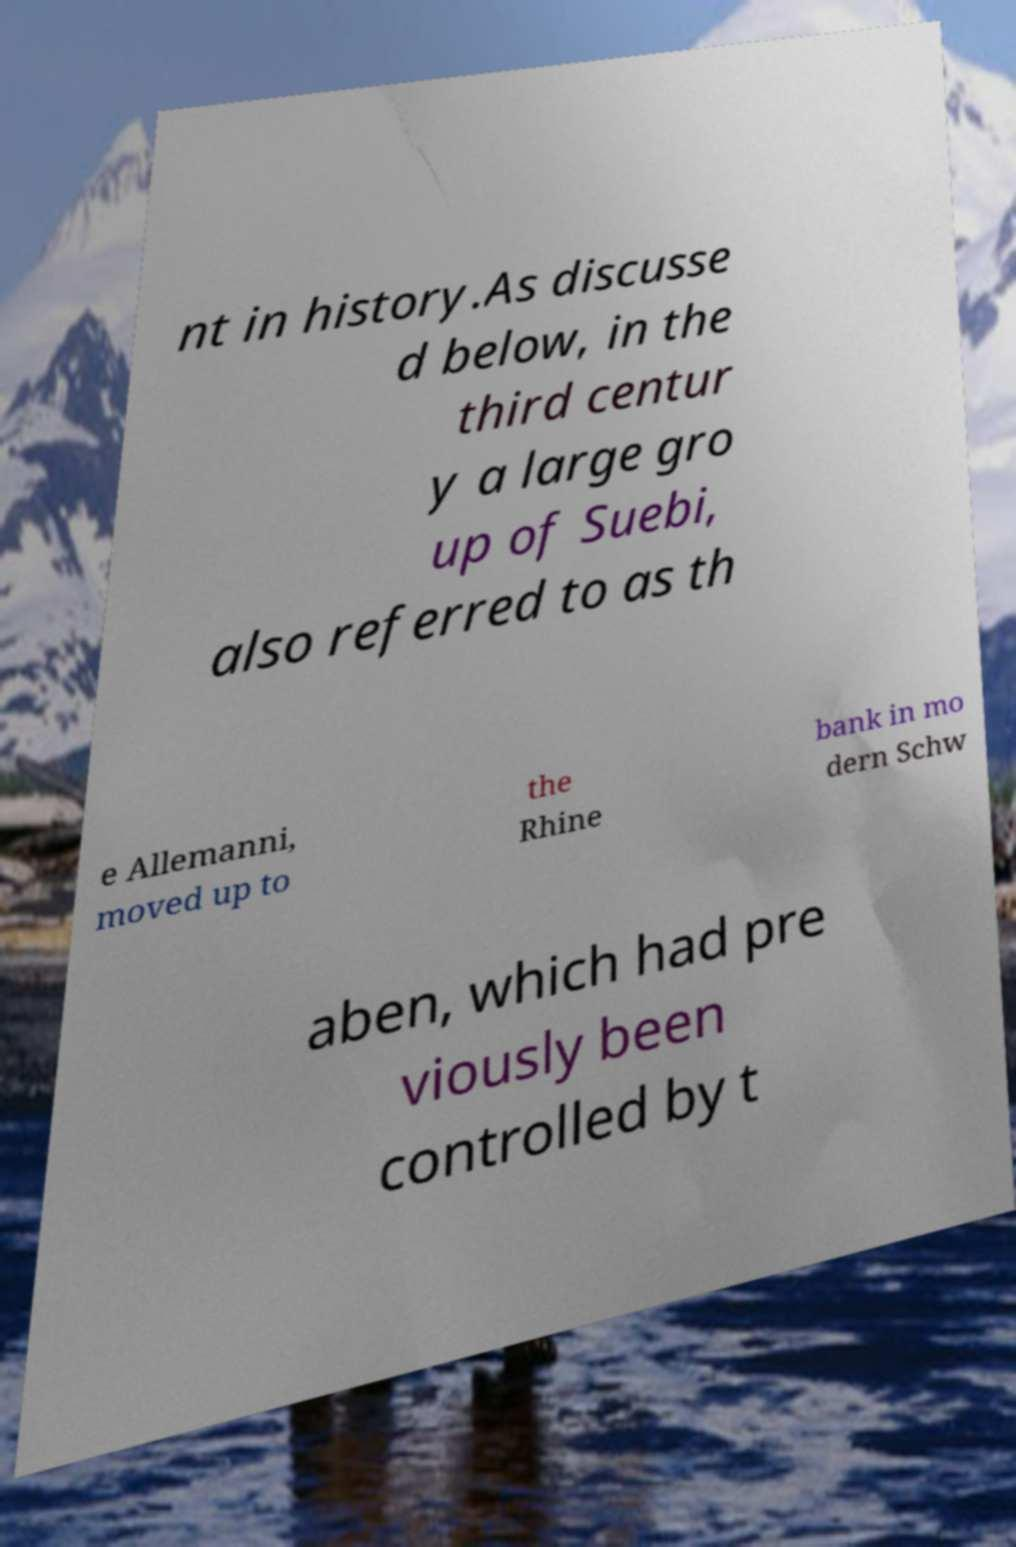Can you read and provide the text displayed in the image?This photo seems to have some interesting text. Can you extract and type it out for me? nt in history.As discusse d below, in the third centur y a large gro up of Suebi, also referred to as th e Allemanni, moved up to the Rhine bank in mo dern Schw aben, which had pre viously been controlled by t 